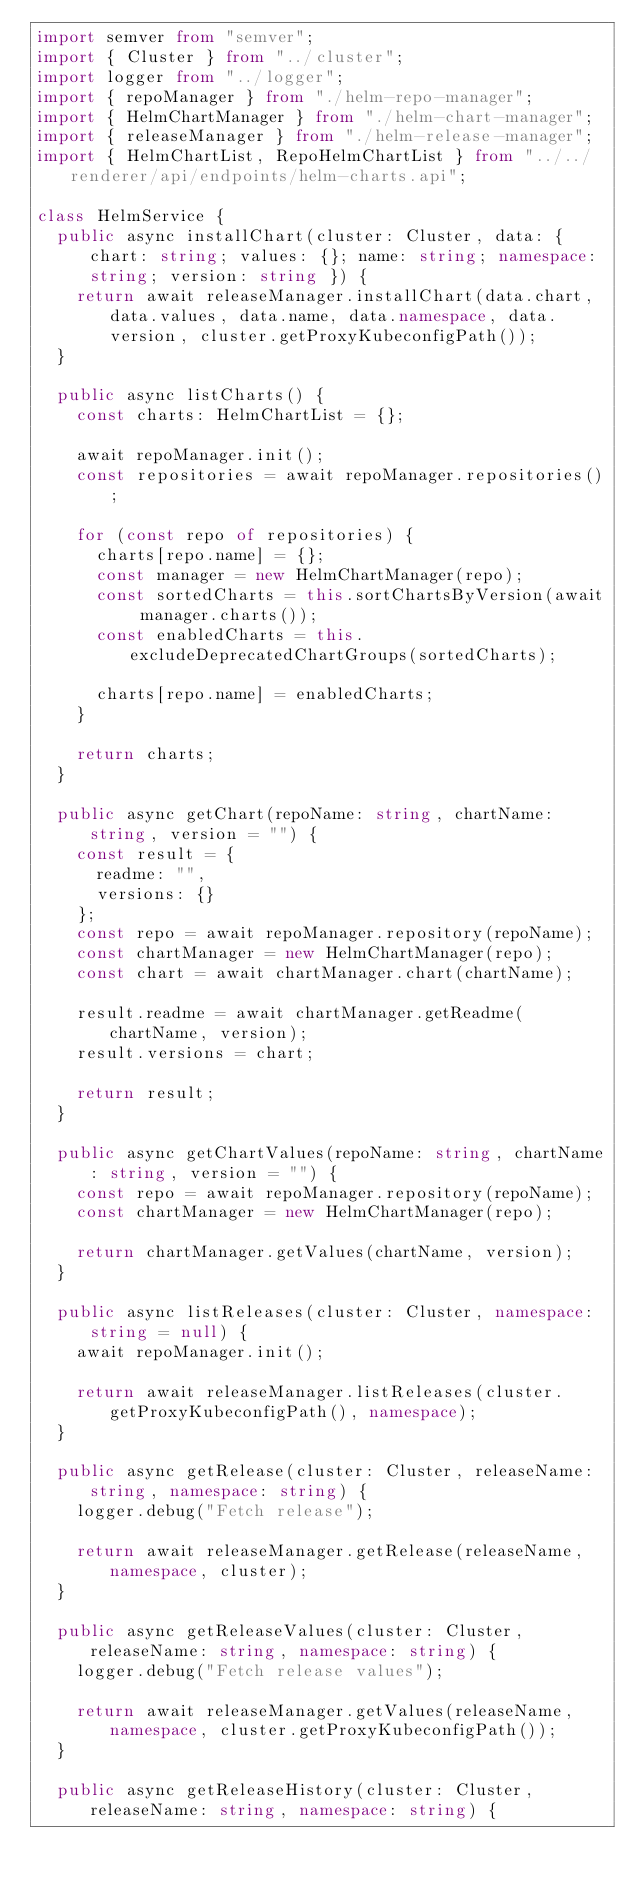Convert code to text. <code><loc_0><loc_0><loc_500><loc_500><_TypeScript_>import semver from "semver";
import { Cluster } from "../cluster";
import logger from "../logger";
import { repoManager } from "./helm-repo-manager";
import { HelmChartManager } from "./helm-chart-manager";
import { releaseManager } from "./helm-release-manager";
import { HelmChartList, RepoHelmChartList } from "../../renderer/api/endpoints/helm-charts.api";

class HelmService {
  public async installChart(cluster: Cluster, data: { chart: string; values: {}; name: string; namespace: string; version: string }) {
    return await releaseManager.installChart(data.chart, data.values, data.name, data.namespace, data.version, cluster.getProxyKubeconfigPath());
  }

  public async listCharts() {
    const charts: HelmChartList = {};

    await repoManager.init();
    const repositories = await repoManager.repositories();

    for (const repo of repositories) {
      charts[repo.name] = {};
      const manager = new HelmChartManager(repo);
      const sortedCharts = this.sortChartsByVersion(await manager.charts());
      const enabledCharts = this.excludeDeprecatedChartGroups(sortedCharts);

      charts[repo.name] = enabledCharts;
    }

    return charts;
  }

  public async getChart(repoName: string, chartName: string, version = "") {
    const result = {
      readme: "",
      versions: {}
    };
    const repo = await repoManager.repository(repoName);
    const chartManager = new HelmChartManager(repo);
    const chart = await chartManager.chart(chartName);

    result.readme = await chartManager.getReadme(chartName, version);
    result.versions = chart;

    return result;
  }

  public async getChartValues(repoName: string, chartName: string, version = "") {
    const repo = await repoManager.repository(repoName);
    const chartManager = new HelmChartManager(repo);

    return chartManager.getValues(chartName, version);
  }

  public async listReleases(cluster: Cluster, namespace: string = null) {
    await repoManager.init();

    return await releaseManager.listReleases(cluster.getProxyKubeconfigPath(), namespace);
  }

  public async getRelease(cluster: Cluster, releaseName: string, namespace: string) {
    logger.debug("Fetch release");

    return await releaseManager.getRelease(releaseName, namespace, cluster);
  }

  public async getReleaseValues(cluster: Cluster, releaseName: string, namespace: string) {
    logger.debug("Fetch release values");

    return await releaseManager.getValues(releaseName, namespace, cluster.getProxyKubeconfigPath());
  }

  public async getReleaseHistory(cluster: Cluster, releaseName: string, namespace: string) {</code> 